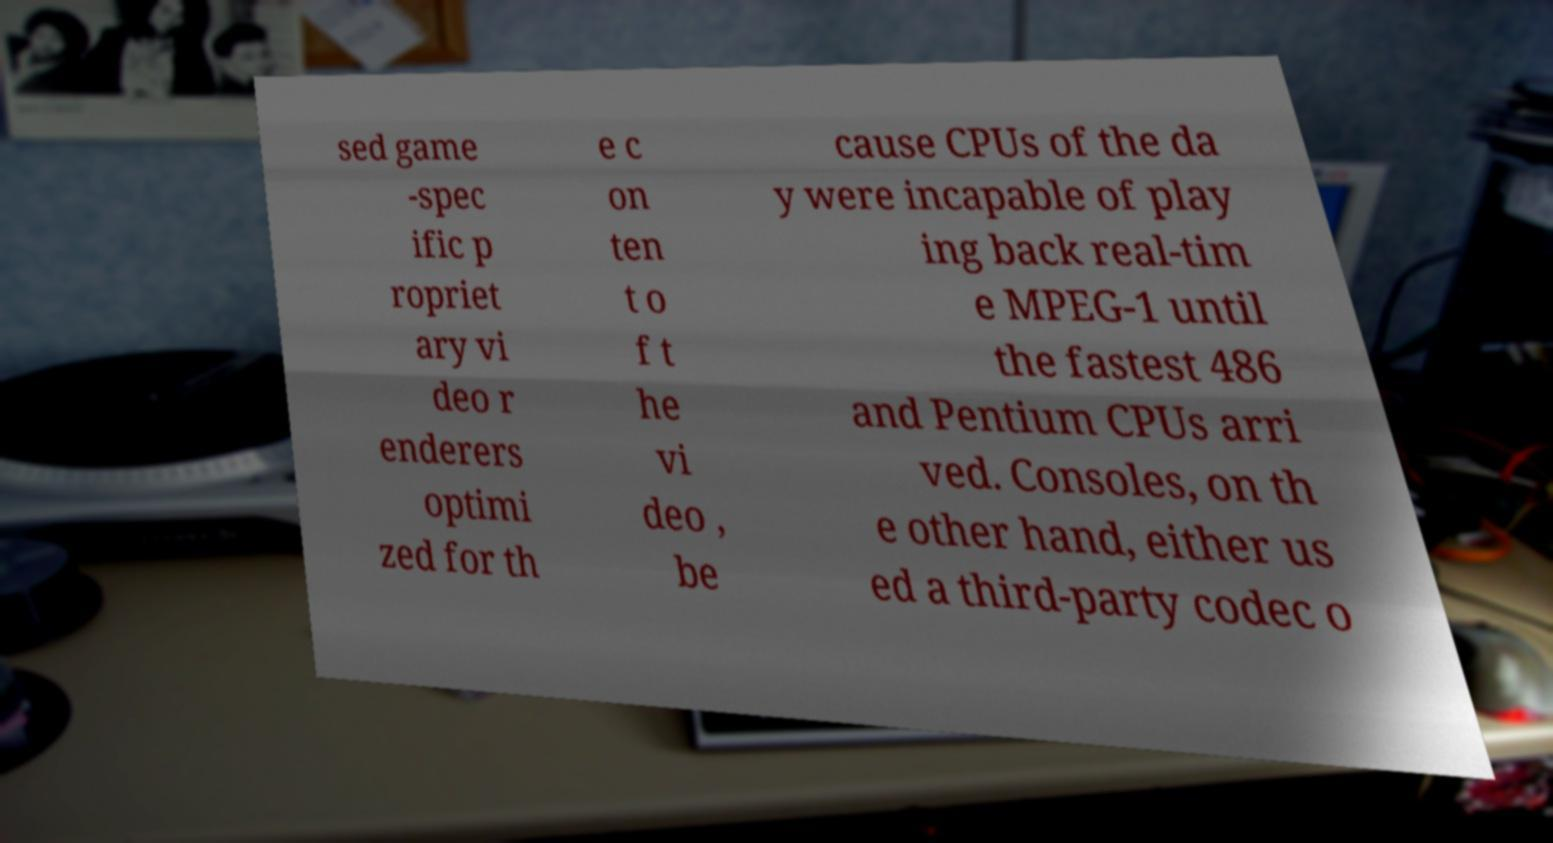Could you assist in decoding the text presented in this image and type it out clearly? sed game -spec ific p ropriet ary vi deo r enderers optimi zed for th e c on ten t o f t he vi deo , be cause CPUs of the da y were incapable of play ing back real-tim e MPEG-1 until the fastest 486 and Pentium CPUs arri ved. Consoles, on th e other hand, either us ed a third-party codec o 